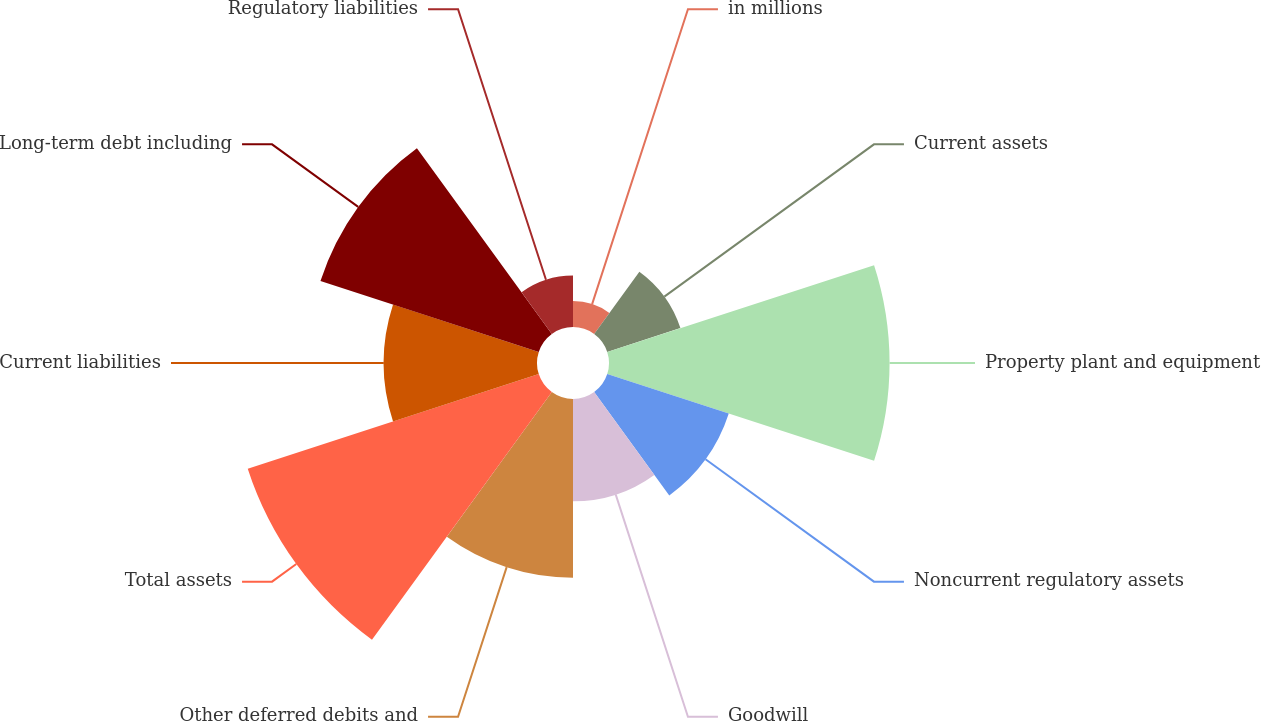Convert chart. <chart><loc_0><loc_0><loc_500><loc_500><pie_chart><fcel>in millions<fcel>Current assets<fcel>Property plant and equipment<fcel>Noncurrent regulatory assets<fcel>Goodwill<fcel>Other deferred debits and<fcel>Total assets<fcel>Current liabilities<fcel>Long-term debt including<fcel>Regulatory liabilities<nl><fcel>1.69%<fcel>5.02%<fcel>18.31%<fcel>8.34%<fcel>6.68%<fcel>11.66%<fcel>19.97%<fcel>10.0%<fcel>14.98%<fcel>3.36%<nl></chart> 